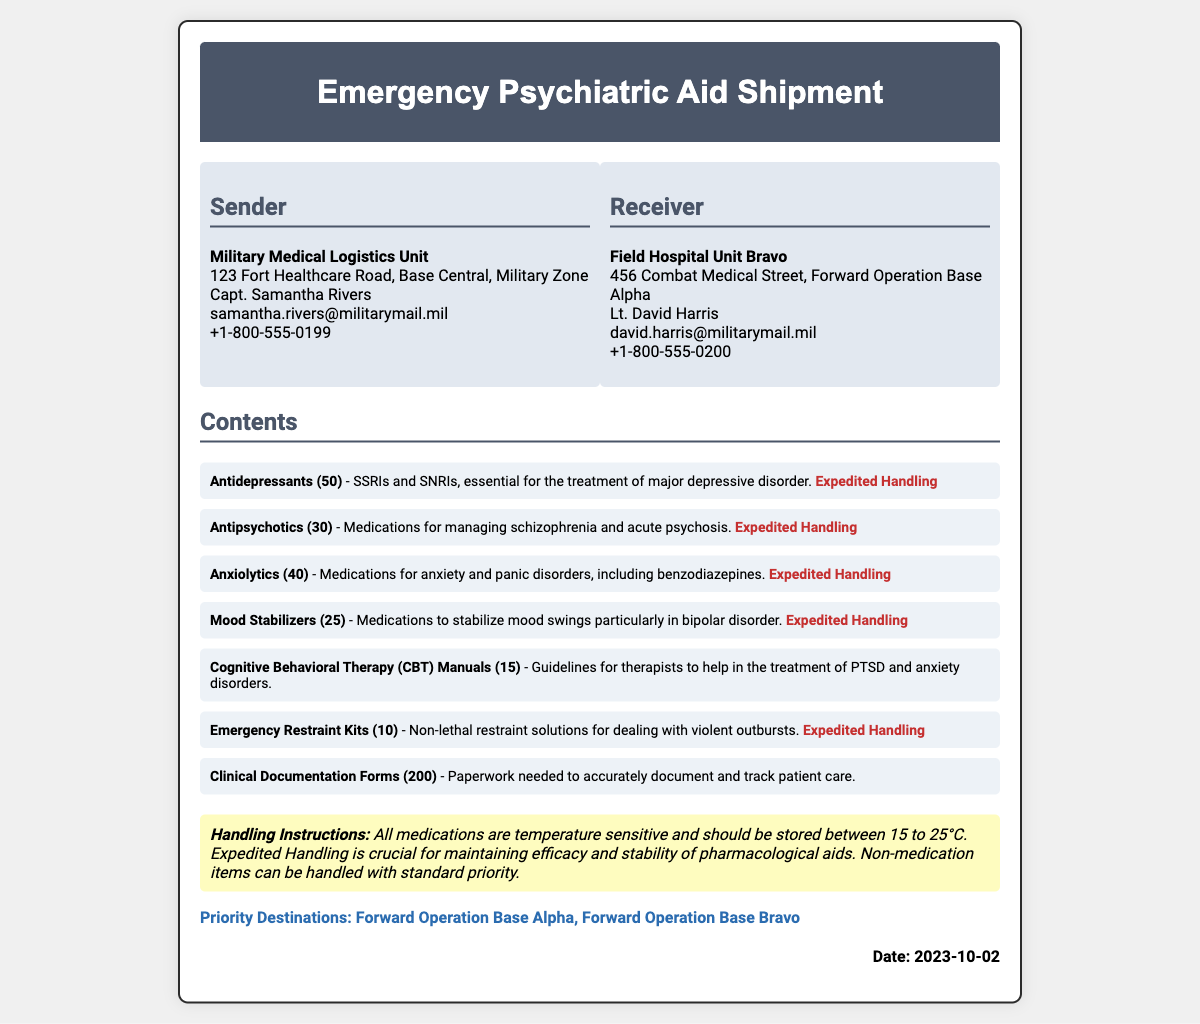what is the date of the shipment? The date is explicitly stated at the bottom of the document.
Answer: 2023-10-02 who is the sender of the shipment? The sender's information is provided under the "Sender" section of the document.
Answer: Military Medical Logistics Unit how many Antidepressants are included in the shipment? The quantity of Antidepressants is listed next to the item in the contents section.
Answer: 50 what type of items require expedited handling? The items requiring expedited handling are marked accordingly in the contents section.
Answer: Antidepressants, Antipsychotics, Anxiolytics, Mood Stabilizers, Emergency Restraint Kits what is the priority destination for this shipment? The priority destinations are listed at the bottom of the document.
Answer: Forward Operation Base Alpha, Forward Operation Base Bravo how many Clinical Documentation Forms are included in the shipment? The number of Clinical Documentation Forms is specified under the contents section.
Answer: 200 what is the handling instruction for medications? The handling instruction for medications is mentioned in the instruction section of the document.
Answer: Temperature sensitive, 15 to 25°C who is the receiver of the shipment? The receiver's details are found under the "Receiver" section of the document.
Answer: Field Hospital Unit Bravo 